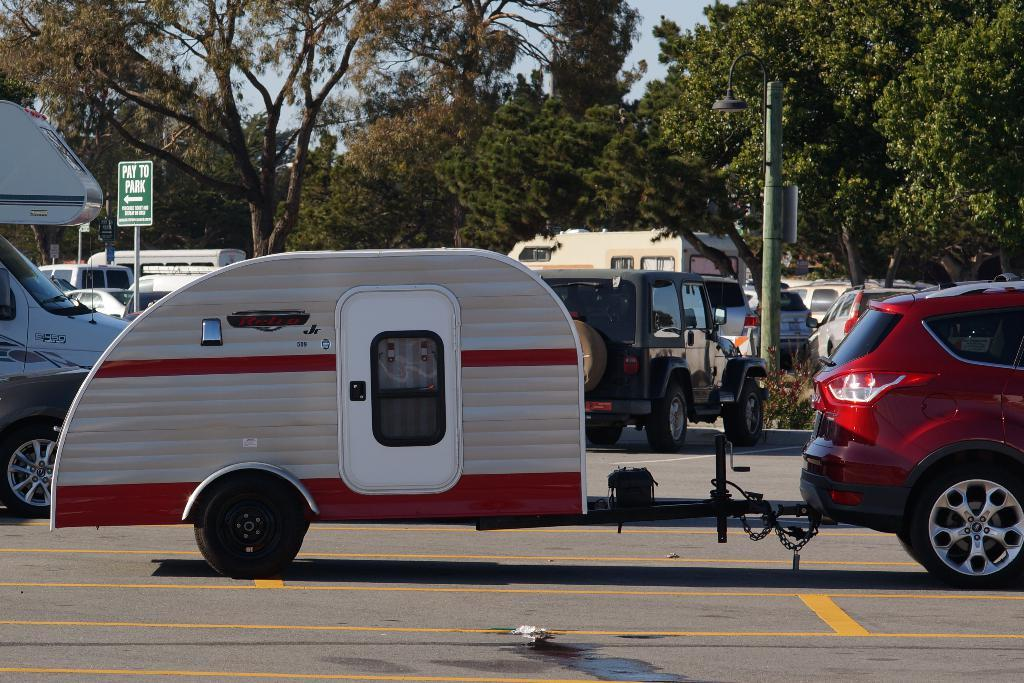<image>
Summarize the visual content of the image. The sign behind the little trailer indicates that you should pay to park to the left. 